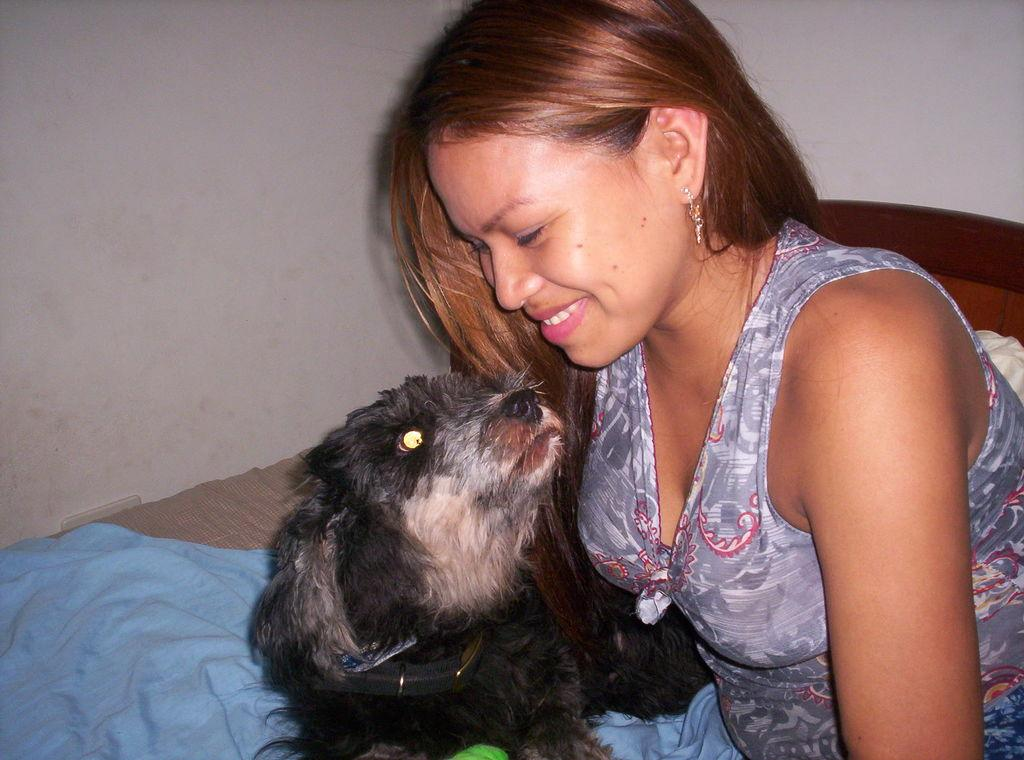What is the woman in the image wearing? The woman in the image is wearing an ash-colored dress. What type of animal can be seen in the image? There is a black-colored dog in the image. What piece of furniture is present in the image? There is a bed in the image. What color is the cloth in the image? The cloth in the image is blue-colored. What color is the wall in the image? The wall in the image is white-colored. What type of cactus can be seen in the image? There is no cactus present in the image. What substance is the woman holding in the image? The provided facts do not mention any substance being held by the woman in the image. 